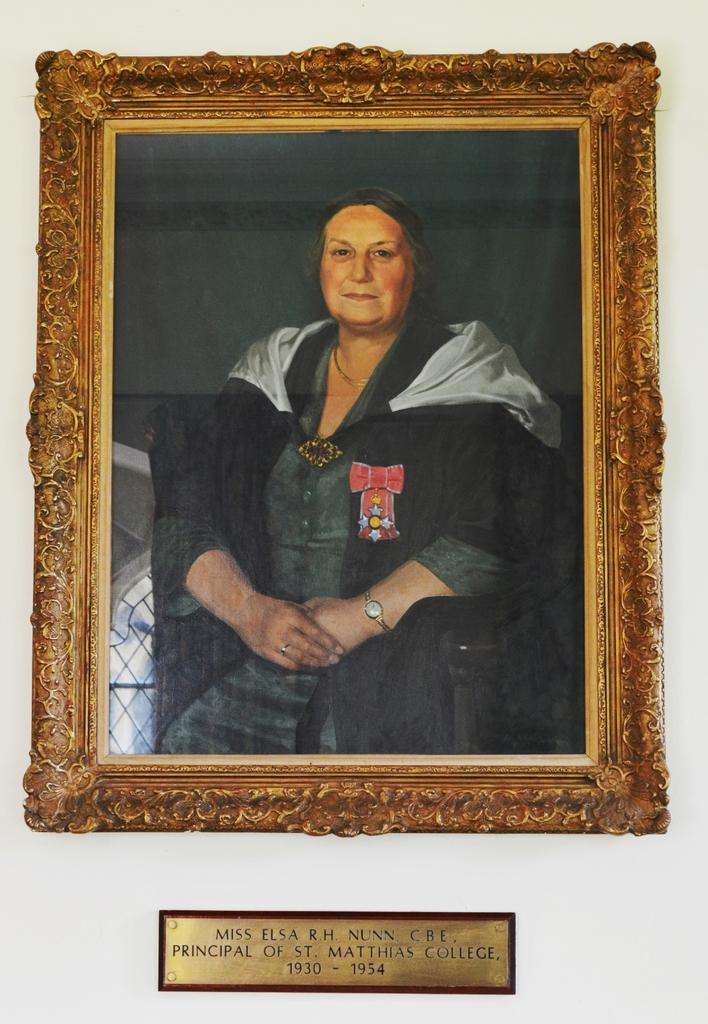What object is present in the image that typically holds a photograph? There is a photo frame in the image. What is depicted inside the photo frame? The photo frame contains an image of a woman. Is there any text associated with the photo frame? Yes, there is text at the bottom of the frame. What is the color of the background in the image? The background of the image is white. Can you see a robin perched on the photo frame in the image? No, there is no robin present in the image. What book is the woman reading in the photo frame? The photo frame contains an image of a woman, but there is no book visible in the image. 